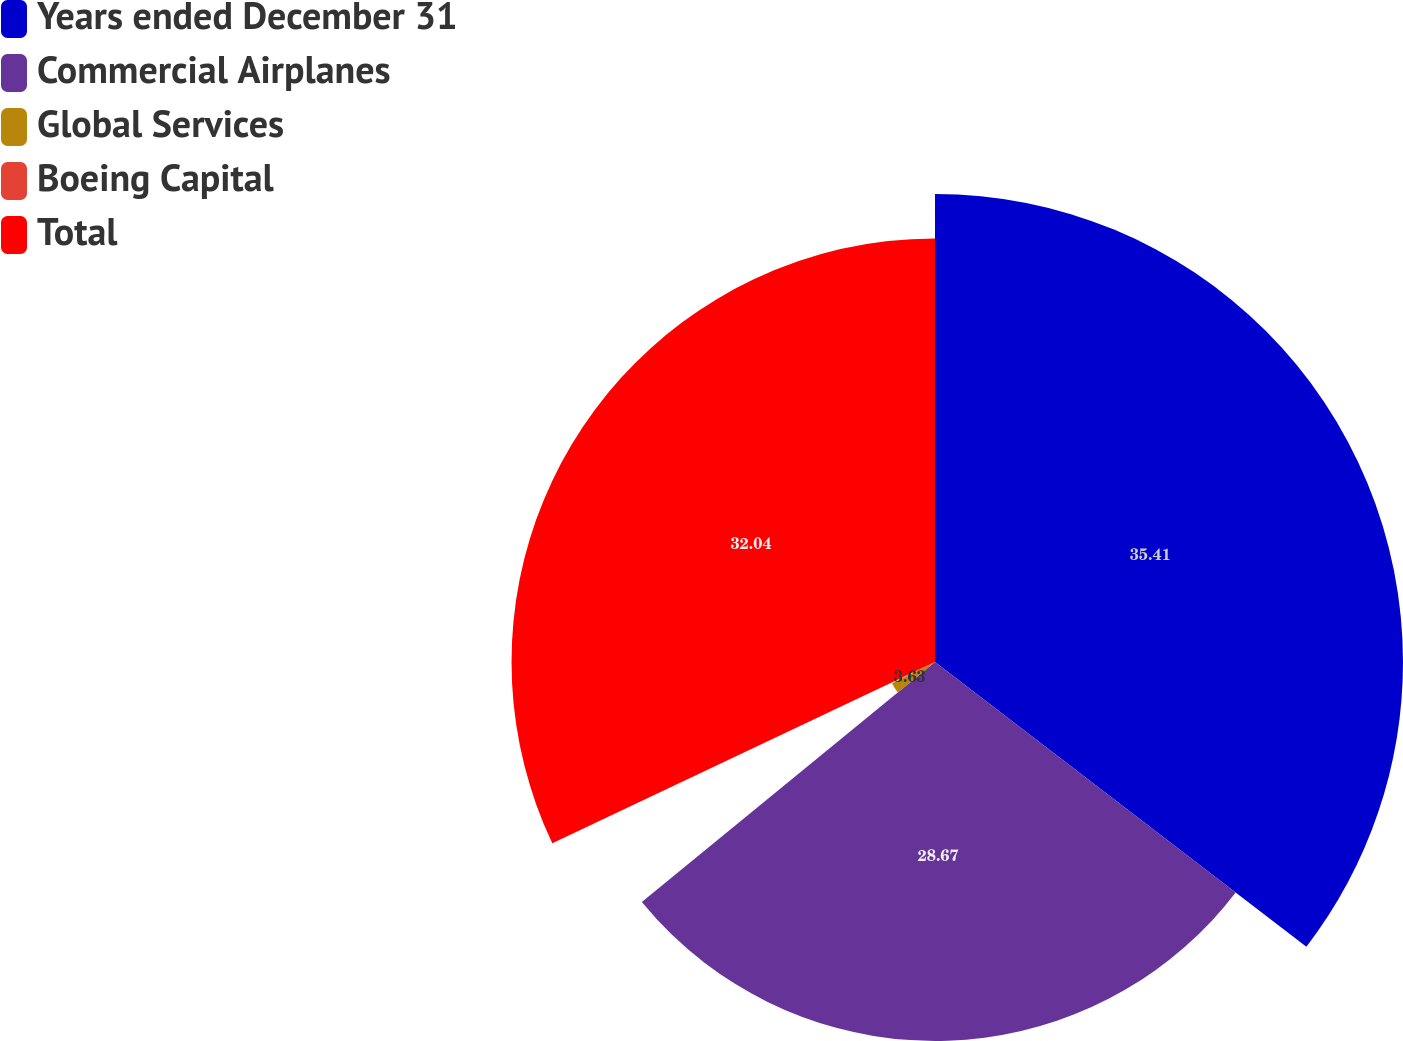<chart> <loc_0><loc_0><loc_500><loc_500><pie_chart><fcel>Years ended December 31<fcel>Commercial Airplanes<fcel>Global Services<fcel>Boeing Capital<fcel>Total<nl><fcel>35.41%<fcel>28.67%<fcel>3.63%<fcel>0.25%<fcel>32.04%<nl></chart> 